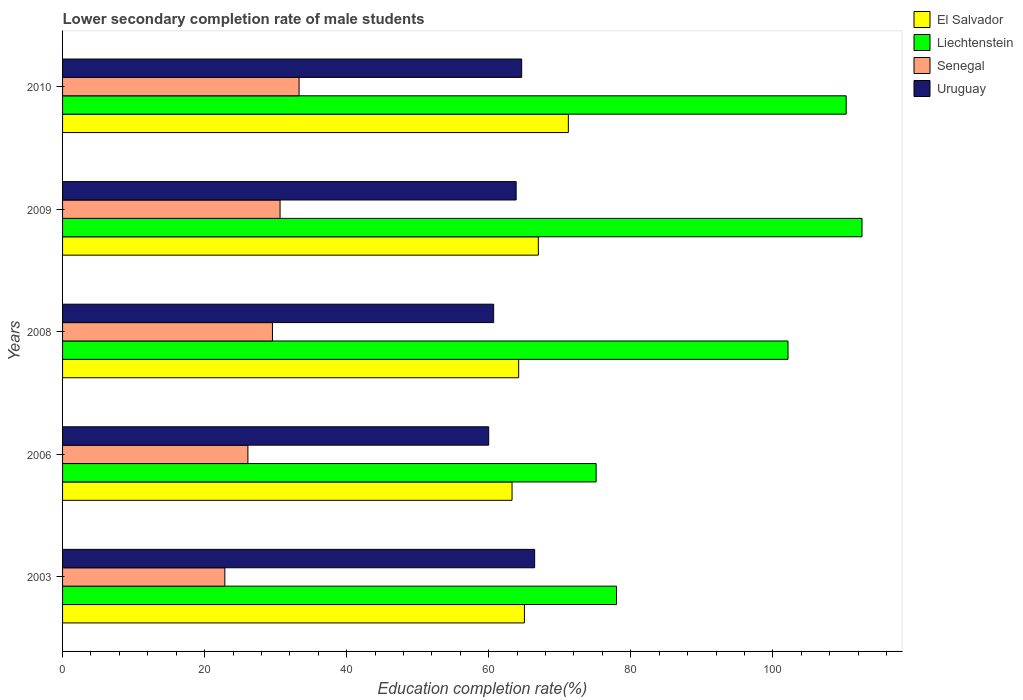Are the number of bars on each tick of the Y-axis equal?
Your response must be concise. Yes. How many bars are there on the 4th tick from the top?
Your answer should be compact. 4. How many bars are there on the 2nd tick from the bottom?
Ensure brevity in your answer.  4. What is the label of the 5th group of bars from the top?
Offer a very short reply. 2003. What is the lower secondary completion rate of male students in Uruguay in 2010?
Give a very brief answer. 64.64. Across all years, what is the maximum lower secondary completion rate of male students in Liechtenstein?
Offer a very short reply. 112.56. Across all years, what is the minimum lower secondary completion rate of male students in Liechtenstein?
Ensure brevity in your answer.  75.12. What is the total lower secondary completion rate of male students in Liechtenstein in the graph?
Offer a terse response. 478.14. What is the difference between the lower secondary completion rate of male students in Liechtenstein in 2006 and that in 2008?
Provide a succinct answer. -27.01. What is the difference between the lower secondary completion rate of male students in Senegal in 2006 and the lower secondary completion rate of male students in El Salvador in 2008?
Keep it short and to the point. -38.12. What is the average lower secondary completion rate of male students in Liechtenstein per year?
Offer a very short reply. 95.63. In the year 2003, what is the difference between the lower secondary completion rate of male students in Liechtenstein and lower secondary completion rate of male students in Uruguay?
Offer a terse response. 11.52. What is the ratio of the lower secondary completion rate of male students in Liechtenstein in 2008 to that in 2009?
Keep it short and to the point. 0.91. Is the lower secondary completion rate of male students in El Salvador in 2006 less than that in 2010?
Your answer should be very brief. Yes. Is the difference between the lower secondary completion rate of male students in Liechtenstein in 2003 and 2010 greater than the difference between the lower secondary completion rate of male students in Uruguay in 2003 and 2010?
Ensure brevity in your answer.  No. What is the difference between the highest and the second highest lower secondary completion rate of male students in El Salvador?
Your answer should be very brief. 4.22. What is the difference between the highest and the lowest lower secondary completion rate of male students in El Salvador?
Your response must be concise. 7.93. What does the 2nd bar from the top in 2008 represents?
Ensure brevity in your answer.  Senegal. What does the 3rd bar from the bottom in 2008 represents?
Offer a very short reply. Senegal. How many years are there in the graph?
Your answer should be very brief. 5. What is the difference between two consecutive major ticks on the X-axis?
Ensure brevity in your answer.  20. Are the values on the major ticks of X-axis written in scientific E-notation?
Provide a short and direct response. No. Does the graph contain any zero values?
Keep it short and to the point. No. What is the title of the graph?
Your answer should be compact. Lower secondary completion rate of male students. Does "Tanzania" appear as one of the legend labels in the graph?
Make the answer very short. No. What is the label or title of the X-axis?
Give a very brief answer. Education completion rate(%). What is the Education completion rate(%) in El Salvador in 2003?
Offer a terse response. 65.03. What is the Education completion rate(%) of Liechtenstein in 2003?
Your answer should be compact. 77.99. What is the Education completion rate(%) in Senegal in 2003?
Your response must be concise. 22.85. What is the Education completion rate(%) of Uruguay in 2003?
Your answer should be very brief. 66.47. What is the Education completion rate(%) in El Salvador in 2006?
Your answer should be compact. 63.29. What is the Education completion rate(%) in Liechtenstein in 2006?
Make the answer very short. 75.12. What is the Education completion rate(%) of Senegal in 2006?
Ensure brevity in your answer.  26.09. What is the Education completion rate(%) of Uruguay in 2006?
Provide a succinct answer. 60. What is the Education completion rate(%) of El Salvador in 2008?
Offer a terse response. 64.22. What is the Education completion rate(%) of Liechtenstein in 2008?
Keep it short and to the point. 102.14. What is the Education completion rate(%) of Senegal in 2008?
Your answer should be very brief. 29.55. What is the Education completion rate(%) of Uruguay in 2008?
Offer a very short reply. 60.69. What is the Education completion rate(%) in El Salvador in 2009?
Ensure brevity in your answer.  66.99. What is the Education completion rate(%) in Liechtenstein in 2009?
Provide a succinct answer. 112.56. What is the Education completion rate(%) of Senegal in 2009?
Offer a terse response. 30.62. What is the Education completion rate(%) of Uruguay in 2009?
Your answer should be very brief. 63.86. What is the Education completion rate(%) in El Salvador in 2010?
Give a very brief answer. 71.21. What is the Education completion rate(%) in Liechtenstein in 2010?
Give a very brief answer. 110.33. What is the Education completion rate(%) of Senegal in 2010?
Your response must be concise. 33.3. What is the Education completion rate(%) of Uruguay in 2010?
Make the answer very short. 64.64. Across all years, what is the maximum Education completion rate(%) of El Salvador?
Make the answer very short. 71.21. Across all years, what is the maximum Education completion rate(%) of Liechtenstein?
Offer a very short reply. 112.56. Across all years, what is the maximum Education completion rate(%) of Senegal?
Your answer should be compact. 33.3. Across all years, what is the maximum Education completion rate(%) of Uruguay?
Give a very brief answer. 66.47. Across all years, what is the minimum Education completion rate(%) of El Salvador?
Provide a short and direct response. 63.29. Across all years, what is the minimum Education completion rate(%) of Liechtenstein?
Provide a short and direct response. 75.12. Across all years, what is the minimum Education completion rate(%) in Senegal?
Give a very brief answer. 22.85. Across all years, what is the minimum Education completion rate(%) of Uruguay?
Your answer should be compact. 60. What is the total Education completion rate(%) in El Salvador in the graph?
Provide a succinct answer. 330.73. What is the total Education completion rate(%) in Liechtenstein in the graph?
Your answer should be very brief. 478.14. What is the total Education completion rate(%) in Senegal in the graph?
Offer a terse response. 142.42. What is the total Education completion rate(%) of Uruguay in the graph?
Keep it short and to the point. 315.66. What is the difference between the Education completion rate(%) in El Salvador in 2003 and that in 2006?
Offer a very short reply. 1.74. What is the difference between the Education completion rate(%) of Liechtenstein in 2003 and that in 2006?
Give a very brief answer. 2.87. What is the difference between the Education completion rate(%) of Senegal in 2003 and that in 2006?
Make the answer very short. -3.25. What is the difference between the Education completion rate(%) of Uruguay in 2003 and that in 2006?
Keep it short and to the point. 6.47. What is the difference between the Education completion rate(%) in El Salvador in 2003 and that in 2008?
Provide a succinct answer. 0.81. What is the difference between the Education completion rate(%) in Liechtenstein in 2003 and that in 2008?
Offer a terse response. -24.15. What is the difference between the Education completion rate(%) of Senegal in 2003 and that in 2008?
Your answer should be very brief. -6.71. What is the difference between the Education completion rate(%) in Uruguay in 2003 and that in 2008?
Provide a succinct answer. 5.77. What is the difference between the Education completion rate(%) of El Salvador in 2003 and that in 2009?
Your response must be concise. -1.96. What is the difference between the Education completion rate(%) of Liechtenstein in 2003 and that in 2009?
Provide a succinct answer. -34.57. What is the difference between the Education completion rate(%) in Senegal in 2003 and that in 2009?
Provide a short and direct response. -7.78. What is the difference between the Education completion rate(%) of Uruguay in 2003 and that in 2009?
Offer a very short reply. 2.6. What is the difference between the Education completion rate(%) in El Salvador in 2003 and that in 2010?
Give a very brief answer. -6.19. What is the difference between the Education completion rate(%) of Liechtenstein in 2003 and that in 2010?
Ensure brevity in your answer.  -32.34. What is the difference between the Education completion rate(%) of Senegal in 2003 and that in 2010?
Ensure brevity in your answer.  -10.45. What is the difference between the Education completion rate(%) in Uruguay in 2003 and that in 2010?
Make the answer very short. 1.83. What is the difference between the Education completion rate(%) of El Salvador in 2006 and that in 2008?
Ensure brevity in your answer.  -0.93. What is the difference between the Education completion rate(%) of Liechtenstein in 2006 and that in 2008?
Keep it short and to the point. -27.01. What is the difference between the Education completion rate(%) of Senegal in 2006 and that in 2008?
Provide a succinct answer. -3.46. What is the difference between the Education completion rate(%) of Uruguay in 2006 and that in 2008?
Provide a short and direct response. -0.7. What is the difference between the Education completion rate(%) in El Salvador in 2006 and that in 2009?
Make the answer very short. -3.7. What is the difference between the Education completion rate(%) of Liechtenstein in 2006 and that in 2009?
Keep it short and to the point. -37.43. What is the difference between the Education completion rate(%) of Senegal in 2006 and that in 2009?
Offer a very short reply. -4.53. What is the difference between the Education completion rate(%) in Uruguay in 2006 and that in 2009?
Your response must be concise. -3.87. What is the difference between the Education completion rate(%) in El Salvador in 2006 and that in 2010?
Your answer should be very brief. -7.93. What is the difference between the Education completion rate(%) of Liechtenstein in 2006 and that in 2010?
Give a very brief answer. -35.2. What is the difference between the Education completion rate(%) of Senegal in 2006 and that in 2010?
Offer a very short reply. -7.2. What is the difference between the Education completion rate(%) in Uruguay in 2006 and that in 2010?
Your answer should be compact. -4.64. What is the difference between the Education completion rate(%) of El Salvador in 2008 and that in 2009?
Provide a short and direct response. -2.77. What is the difference between the Education completion rate(%) in Liechtenstein in 2008 and that in 2009?
Your answer should be compact. -10.42. What is the difference between the Education completion rate(%) in Senegal in 2008 and that in 2009?
Your answer should be compact. -1.07. What is the difference between the Education completion rate(%) of Uruguay in 2008 and that in 2009?
Provide a succinct answer. -3.17. What is the difference between the Education completion rate(%) of El Salvador in 2008 and that in 2010?
Provide a succinct answer. -6.99. What is the difference between the Education completion rate(%) in Liechtenstein in 2008 and that in 2010?
Provide a short and direct response. -8.19. What is the difference between the Education completion rate(%) in Senegal in 2008 and that in 2010?
Your response must be concise. -3.75. What is the difference between the Education completion rate(%) in Uruguay in 2008 and that in 2010?
Give a very brief answer. -3.94. What is the difference between the Education completion rate(%) in El Salvador in 2009 and that in 2010?
Your answer should be very brief. -4.22. What is the difference between the Education completion rate(%) of Liechtenstein in 2009 and that in 2010?
Provide a short and direct response. 2.23. What is the difference between the Education completion rate(%) in Senegal in 2009 and that in 2010?
Offer a terse response. -2.68. What is the difference between the Education completion rate(%) of Uruguay in 2009 and that in 2010?
Make the answer very short. -0.77. What is the difference between the Education completion rate(%) of El Salvador in 2003 and the Education completion rate(%) of Liechtenstein in 2006?
Give a very brief answer. -10.1. What is the difference between the Education completion rate(%) in El Salvador in 2003 and the Education completion rate(%) in Senegal in 2006?
Your response must be concise. 38.93. What is the difference between the Education completion rate(%) in El Salvador in 2003 and the Education completion rate(%) in Uruguay in 2006?
Your response must be concise. 5.03. What is the difference between the Education completion rate(%) in Liechtenstein in 2003 and the Education completion rate(%) in Senegal in 2006?
Offer a very short reply. 51.9. What is the difference between the Education completion rate(%) in Liechtenstein in 2003 and the Education completion rate(%) in Uruguay in 2006?
Make the answer very short. 17.99. What is the difference between the Education completion rate(%) of Senegal in 2003 and the Education completion rate(%) of Uruguay in 2006?
Your answer should be very brief. -37.15. What is the difference between the Education completion rate(%) in El Salvador in 2003 and the Education completion rate(%) in Liechtenstein in 2008?
Offer a very short reply. -37.11. What is the difference between the Education completion rate(%) of El Salvador in 2003 and the Education completion rate(%) of Senegal in 2008?
Keep it short and to the point. 35.47. What is the difference between the Education completion rate(%) of El Salvador in 2003 and the Education completion rate(%) of Uruguay in 2008?
Give a very brief answer. 4.33. What is the difference between the Education completion rate(%) in Liechtenstein in 2003 and the Education completion rate(%) in Senegal in 2008?
Your response must be concise. 48.44. What is the difference between the Education completion rate(%) of Liechtenstein in 2003 and the Education completion rate(%) of Uruguay in 2008?
Keep it short and to the point. 17.3. What is the difference between the Education completion rate(%) of Senegal in 2003 and the Education completion rate(%) of Uruguay in 2008?
Provide a succinct answer. -37.85. What is the difference between the Education completion rate(%) in El Salvador in 2003 and the Education completion rate(%) in Liechtenstein in 2009?
Give a very brief answer. -47.53. What is the difference between the Education completion rate(%) in El Salvador in 2003 and the Education completion rate(%) in Senegal in 2009?
Offer a terse response. 34.4. What is the difference between the Education completion rate(%) in El Salvador in 2003 and the Education completion rate(%) in Uruguay in 2009?
Make the answer very short. 1.16. What is the difference between the Education completion rate(%) of Liechtenstein in 2003 and the Education completion rate(%) of Senegal in 2009?
Your response must be concise. 47.37. What is the difference between the Education completion rate(%) of Liechtenstein in 2003 and the Education completion rate(%) of Uruguay in 2009?
Make the answer very short. 14.13. What is the difference between the Education completion rate(%) in Senegal in 2003 and the Education completion rate(%) in Uruguay in 2009?
Your response must be concise. -41.02. What is the difference between the Education completion rate(%) in El Salvador in 2003 and the Education completion rate(%) in Liechtenstein in 2010?
Provide a short and direct response. -45.3. What is the difference between the Education completion rate(%) of El Salvador in 2003 and the Education completion rate(%) of Senegal in 2010?
Your answer should be compact. 31.73. What is the difference between the Education completion rate(%) of El Salvador in 2003 and the Education completion rate(%) of Uruguay in 2010?
Provide a short and direct response. 0.39. What is the difference between the Education completion rate(%) of Liechtenstein in 2003 and the Education completion rate(%) of Senegal in 2010?
Your answer should be compact. 44.69. What is the difference between the Education completion rate(%) in Liechtenstein in 2003 and the Education completion rate(%) in Uruguay in 2010?
Keep it short and to the point. 13.35. What is the difference between the Education completion rate(%) in Senegal in 2003 and the Education completion rate(%) in Uruguay in 2010?
Keep it short and to the point. -41.79. What is the difference between the Education completion rate(%) of El Salvador in 2006 and the Education completion rate(%) of Liechtenstein in 2008?
Give a very brief answer. -38.85. What is the difference between the Education completion rate(%) in El Salvador in 2006 and the Education completion rate(%) in Senegal in 2008?
Ensure brevity in your answer.  33.73. What is the difference between the Education completion rate(%) in El Salvador in 2006 and the Education completion rate(%) in Uruguay in 2008?
Offer a terse response. 2.59. What is the difference between the Education completion rate(%) of Liechtenstein in 2006 and the Education completion rate(%) of Senegal in 2008?
Give a very brief answer. 45.57. What is the difference between the Education completion rate(%) in Liechtenstein in 2006 and the Education completion rate(%) in Uruguay in 2008?
Provide a succinct answer. 14.43. What is the difference between the Education completion rate(%) of Senegal in 2006 and the Education completion rate(%) of Uruguay in 2008?
Your answer should be compact. -34.6. What is the difference between the Education completion rate(%) of El Salvador in 2006 and the Education completion rate(%) of Liechtenstein in 2009?
Ensure brevity in your answer.  -49.27. What is the difference between the Education completion rate(%) in El Salvador in 2006 and the Education completion rate(%) in Senegal in 2009?
Provide a short and direct response. 32.66. What is the difference between the Education completion rate(%) of El Salvador in 2006 and the Education completion rate(%) of Uruguay in 2009?
Your response must be concise. -0.58. What is the difference between the Education completion rate(%) of Liechtenstein in 2006 and the Education completion rate(%) of Senegal in 2009?
Your answer should be very brief. 44.5. What is the difference between the Education completion rate(%) in Liechtenstein in 2006 and the Education completion rate(%) in Uruguay in 2009?
Ensure brevity in your answer.  11.26. What is the difference between the Education completion rate(%) of Senegal in 2006 and the Education completion rate(%) of Uruguay in 2009?
Give a very brief answer. -37.77. What is the difference between the Education completion rate(%) of El Salvador in 2006 and the Education completion rate(%) of Liechtenstein in 2010?
Make the answer very short. -47.04. What is the difference between the Education completion rate(%) of El Salvador in 2006 and the Education completion rate(%) of Senegal in 2010?
Offer a very short reply. 29.99. What is the difference between the Education completion rate(%) of El Salvador in 2006 and the Education completion rate(%) of Uruguay in 2010?
Provide a succinct answer. -1.35. What is the difference between the Education completion rate(%) of Liechtenstein in 2006 and the Education completion rate(%) of Senegal in 2010?
Provide a succinct answer. 41.83. What is the difference between the Education completion rate(%) in Liechtenstein in 2006 and the Education completion rate(%) in Uruguay in 2010?
Ensure brevity in your answer.  10.49. What is the difference between the Education completion rate(%) of Senegal in 2006 and the Education completion rate(%) of Uruguay in 2010?
Offer a terse response. -38.54. What is the difference between the Education completion rate(%) in El Salvador in 2008 and the Education completion rate(%) in Liechtenstein in 2009?
Provide a short and direct response. -48.34. What is the difference between the Education completion rate(%) in El Salvador in 2008 and the Education completion rate(%) in Senegal in 2009?
Your answer should be compact. 33.59. What is the difference between the Education completion rate(%) in El Salvador in 2008 and the Education completion rate(%) in Uruguay in 2009?
Give a very brief answer. 0.35. What is the difference between the Education completion rate(%) in Liechtenstein in 2008 and the Education completion rate(%) in Senegal in 2009?
Your answer should be compact. 71.52. What is the difference between the Education completion rate(%) in Liechtenstein in 2008 and the Education completion rate(%) in Uruguay in 2009?
Give a very brief answer. 38.28. What is the difference between the Education completion rate(%) in Senegal in 2008 and the Education completion rate(%) in Uruguay in 2009?
Provide a succinct answer. -34.31. What is the difference between the Education completion rate(%) in El Salvador in 2008 and the Education completion rate(%) in Liechtenstein in 2010?
Provide a succinct answer. -46.11. What is the difference between the Education completion rate(%) of El Salvador in 2008 and the Education completion rate(%) of Senegal in 2010?
Your answer should be very brief. 30.92. What is the difference between the Education completion rate(%) of El Salvador in 2008 and the Education completion rate(%) of Uruguay in 2010?
Your answer should be compact. -0.42. What is the difference between the Education completion rate(%) in Liechtenstein in 2008 and the Education completion rate(%) in Senegal in 2010?
Make the answer very short. 68.84. What is the difference between the Education completion rate(%) in Liechtenstein in 2008 and the Education completion rate(%) in Uruguay in 2010?
Make the answer very short. 37.5. What is the difference between the Education completion rate(%) in Senegal in 2008 and the Education completion rate(%) in Uruguay in 2010?
Your answer should be very brief. -35.09. What is the difference between the Education completion rate(%) in El Salvador in 2009 and the Education completion rate(%) in Liechtenstein in 2010?
Ensure brevity in your answer.  -43.34. What is the difference between the Education completion rate(%) in El Salvador in 2009 and the Education completion rate(%) in Senegal in 2010?
Provide a succinct answer. 33.69. What is the difference between the Education completion rate(%) in El Salvador in 2009 and the Education completion rate(%) in Uruguay in 2010?
Ensure brevity in your answer.  2.35. What is the difference between the Education completion rate(%) in Liechtenstein in 2009 and the Education completion rate(%) in Senegal in 2010?
Ensure brevity in your answer.  79.26. What is the difference between the Education completion rate(%) in Liechtenstein in 2009 and the Education completion rate(%) in Uruguay in 2010?
Offer a terse response. 47.92. What is the difference between the Education completion rate(%) in Senegal in 2009 and the Education completion rate(%) in Uruguay in 2010?
Provide a succinct answer. -34.02. What is the average Education completion rate(%) in El Salvador per year?
Ensure brevity in your answer.  66.15. What is the average Education completion rate(%) in Liechtenstein per year?
Offer a terse response. 95.63. What is the average Education completion rate(%) in Senegal per year?
Your answer should be compact. 28.48. What is the average Education completion rate(%) in Uruguay per year?
Your answer should be compact. 63.13. In the year 2003, what is the difference between the Education completion rate(%) of El Salvador and Education completion rate(%) of Liechtenstein?
Ensure brevity in your answer.  -12.96. In the year 2003, what is the difference between the Education completion rate(%) of El Salvador and Education completion rate(%) of Senegal?
Provide a succinct answer. 42.18. In the year 2003, what is the difference between the Education completion rate(%) of El Salvador and Education completion rate(%) of Uruguay?
Give a very brief answer. -1.44. In the year 2003, what is the difference between the Education completion rate(%) of Liechtenstein and Education completion rate(%) of Senegal?
Offer a terse response. 55.14. In the year 2003, what is the difference between the Education completion rate(%) in Liechtenstein and Education completion rate(%) in Uruguay?
Make the answer very short. 11.52. In the year 2003, what is the difference between the Education completion rate(%) in Senegal and Education completion rate(%) in Uruguay?
Offer a terse response. -43.62. In the year 2006, what is the difference between the Education completion rate(%) in El Salvador and Education completion rate(%) in Liechtenstein?
Provide a succinct answer. -11.84. In the year 2006, what is the difference between the Education completion rate(%) in El Salvador and Education completion rate(%) in Senegal?
Offer a terse response. 37.19. In the year 2006, what is the difference between the Education completion rate(%) of El Salvador and Education completion rate(%) of Uruguay?
Provide a short and direct response. 3.29. In the year 2006, what is the difference between the Education completion rate(%) of Liechtenstein and Education completion rate(%) of Senegal?
Keep it short and to the point. 49.03. In the year 2006, what is the difference between the Education completion rate(%) of Liechtenstein and Education completion rate(%) of Uruguay?
Your answer should be compact. 15.13. In the year 2006, what is the difference between the Education completion rate(%) in Senegal and Education completion rate(%) in Uruguay?
Provide a succinct answer. -33.9. In the year 2008, what is the difference between the Education completion rate(%) in El Salvador and Education completion rate(%) in Liechtenstein?
Offer a terse response. -37.92. In the year 2008, what is the difference between the Education completion rate(%) of El Salvador and Education completion rate(%) of Senegal?
Offer a very short reply. 34.66. In the year 2008, what is the difference between the Education completion rate(%) in El Salvador and Education completion rate(%) in Uruguay?
Your answer should be very brief. 3.52. In the year 2008, what is the difference between the Education completion rate(%) of Liechtenstein and Education completion rate(%) of Senegal?
Offer a very short reply. 72.59. In the year 2008, what is the difference between the Education completion rate(%) of Liechtenstein and Education completion rate(%) of Uruguay?
Offer a terse response. 41.45. In the year 2008, what is the difference between the Education completion rate(%) in Senegal and Education completion rate(%) in Uruguay?
Give a very brief answer. -31.14. In the year 2009, what is the difference between the Education completion rate(%) of El Salvador and Education completion rate(%) of Liechtenstein?
Give a very brief answer. -45.57. In the year 2009, what is the difference between the Education completion rate(%) in El Salvador and Education completion rate(%) in Senegal?
Ensure brevity in your answer.  36.36. In the year 2009, what is the difference between the Education completion rate(%) of El Salvador and Education completion rate(%) of Uruguay?
Make the answer very short. 3.12. In the year 2009, what is the difference between the Education completion rate(%) in Liechtenstein and Education completion rate(%) in Senegal?
Your answer should be compact. 81.94. In the year 2009, what is the difference between the Education completion rate(%) in Liechtenstein and Education completion rate(%) in Uruguay?
Offer a terse response. 48.69. In the year 2009, what is the difference between the Education completion rate(%) of Senegal and Education completion rate(%) of Uruguay?
Keep it short and to the point. -33.24. In the year 2010, what is the difference between the Education completion rate(%) of El Salvador and Education completion rate(%) of Liechtenstein?
Your response must be concise. -39.12. In the year 2010, what is the difference between the Education completion rate(%) of El Salvador and Education completion rate(%) of Senegal?
Keep it short and to the point. 37.91. In the year 2010, what is the difference between the Education completion rate(%) in El Salvador and Education completion rate(%) in Uruguay?
Your answer should be compact. 6.57. In the year 2010, what is the difference between the Education completion rate(%) of Liechtenstein and Education completion rate(%) of Senegal?
Your response must be concise. 77.03. In the year 2010, what is the difference between the Education completion rate(%) in Liechtenstein and Education completion rate(%) in Uruguay?
Your answer should be compact. 45.69. In the year 2010, what is the difference between the Education completion rate(%) of Senegal and Education completion rate(%) of Uruguay?
Offer a very short reply. -31.34. What is the ratio of the Education completion rate(%) in El Salvador in 2003 to that in 2006?
Your answer should be very brief. 1.03. What is the ratio of the Education completion rate(%) in Liechtenstein in 2003 to that in 2006?
Your response must be concise. 1.04. What is the ratio of the Education completion rate(%) of Senegal in 2003 to that in 2006?
Make the answer very short. 0.88. What is the ratio of the Education completion rate(%) in Uruguay in 2003 to that in 2006?
Offer a very short reply. 1.11. What is the ratio of the Education completion rate(%) in El Salvador in 2003 to that in 2008?
Offer a very short reply. 1.01. What is the ratio of the Education completion rate(%) of Liechtenstein in 2003 to that in 2008?
Give a very brief answer. 0.76. What is the ratio of the Education completion rate(%) in Senegal in 2003 to that in 2008?
Provide a succinct answer. 0.77. What is the ratio of the Education completion rate(%) of Uruguay in 2003 to that in 2008?
Provide a short and direct response. 1.1. What is the ratio of the Education completion rate(%) in El Salvador in 2003 to that in 2009?
Your answer should be compact. 0.97. What is the ratio of the Education completion rate(%) in Liechtenstein in 2003 to that in 2009?
Make the answer very short. 0.69. What is the ratio of the Education completion rate(%) in Senegal in 2003 to that in 2009?
Your answer should be compact. 0.75. What is the ratio of the Education completion rate(%) of Uruguay in 2003 to that in 2009?
Your response must be concise. 1.04. What is the ratio of the Education completion rate(%) of El Salvador in 2003 to that in 2010?
Provide a succinct answer. 0.91. What is the ratio of the Education completion rate(%) in Liechtenstein in 2003 to that in 2010?
Offer a terse response. 0.71. What is the ratio of the Education completion rate(%) in Senegal in 2003 to that in 2010?
Your answer should be very brief. 0.69. What is the ratio of the Education completion rate(%) in Uruguay in 2003 to that in 2010?
Provide a short and direct response. 1.03. What is the ratio of the Education completion rate(%) in El Salvador in 2006 to that in 2008?
Keep it short and to the point. 0.99. What is the ratio of the Education completion rate(%) of Liechtenstein in 2006 to that in 2008?
Your answer should be compact. 0.74. What is the ratio of the Education completion rate(%) in Senegal in 2006 to that in 2008?
Give a very brief answer. 0.88. What is the ratio of the Education completion rate(%) of El Salvador in 2006 to that in 2009?
Provide a succinct answer. 0.94. What is the ratio of the Education completion rate(%) in Liechtenstein in 2006 to that in 2009?
Offer a very short reply. 0.67. What is the ratio of the Education completion rate(%) of Senegal in 2006 to that in 2009?
Your response must be concise. 0.85. What is the ratio of the Education completion rate(%) of Uruguay in 2006 to that in 2009?
Make the answer very short. 0.94. What is the ratio of the Education completion rate(%) in El Salvador in 2006 to that in 2010?
Give a very brief answer. 0.89. What is the ratio of the Education completion rate(%) in Liechtenstein in 2006 to that in 2010?
Provide a succinct answer. 0.68. What is the ratio of the Education completion rate(%) of Senegal in 2006 to that in 2010?
Keep it short and to the point. 0.78. What is the ratio of the Education completion rate(%) in Uruguay in 2006 to that in 2010?
Keep it short and to the point. 0.93. What is the ratio of the Education completion rate(%) in El Salvador in 2008 to that in 2009?
Provide a short and direct response. 0.96. What is the ratio of the Education completion rate(%) of Liechtenstein in 2008 to that in 2009?
Your answer should be compact. 0.91. What is the ratio of the Education completion rate(%) of Senegal in 2008 to that in 2009?
Offer a terse response. 0.97. What is the ratio of the Education completion rate(%) in Uruguay in 2008 to that in 2009?
Make the answer very short. 0.95. What is the ratio of the Education completion rate(%) of El Salvador in 2008 to that in 2010?
Provide a short and direct response. 0.9. What is the ratio of the Education completion rate(%) of Liechtenstein in 2008 to that in 2010?
Give a very brief answer. 0.93. What is the ratio of the Education completion rate(%) of Senegal in 2008 to that in 2010?
Your answer should be compact. 0.89. What is the ratio of the Education completion rate(%) in Uruguay in 2008 to that in 2010?
Provide a succinct answer. 0.94. What is the ratio of the Education completion rate(%) in El Salvador in 2009 to that in 2010?
Provide a succinct answer. 0.94. What is the ratio of the Education completion rate(%) of Liechtenstein in 2009 to that in 2010?
Your response must be concise. 1.02. What is the ratio of the Education completion rate(%) of Senegal in 2009 to that in 2010?
Ensure brevity in your answer.  0.92. What is the difference between the highest and the second highest Education completion rate(%) in El Salvador?
Offer a very short reply. 4.22. What is the difference between the highest and the second highest Education completion rate(%) in Liechtenstein?
Provide a succinct answer. 2.23. What is the difference between the highest and the second highest Education completion rate(%) of Senegal?
Your answer should be very brief. 2.68. What is the difference between the highest and the second highest Education completion rate(%) of Uruguay?
Provide a succinct answer. 1.83. What is the difference between the highest and the lowest Education completion rate(%) of El Salvador?
Offer a very short reply. 7.93. What is the difference between the highest and the lowest Education completion rate(%) of Liechtenstein?
Make the answer very short. 37.43. What is the difference between the highest and the lowest Education completion rate(%) of Senegal?
Keep it short and to the point. 10.45. What is the difference between the highest and the lowest Education completion rate(%) of Uruguay?
Ensure brevity in your answer.  6.47. 